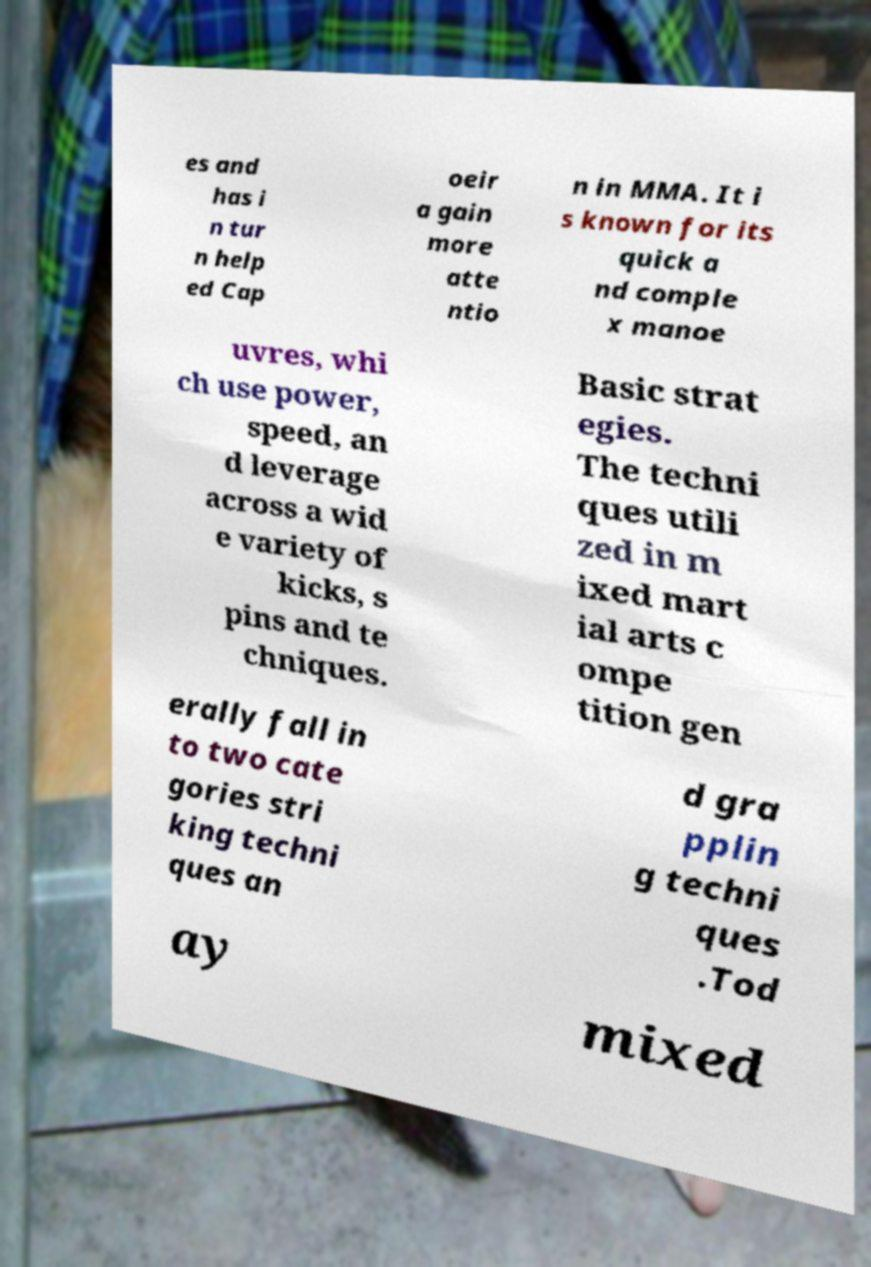Please identify and transcribe the text found in this image. es and has i n tur n help ed Cap oeir a gain more atte ntio n in MMA. It i s known for its quick a nd comple x manoe uvres, whi ch use power, speed, an d leverage across a wid e variety of kicks, s pins and te chniques. Basic strat egies. The techni ques utili zed in m ixed mart ial arts c ompe tition gen erally fall in to two cate gories stri king techni ques an d gra pplin g techni ques .Tod ay mixed 